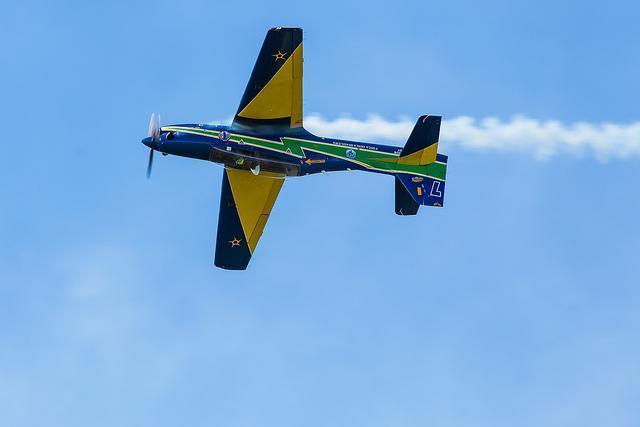How many people are laying down?
Give a very brief answer. 0. 